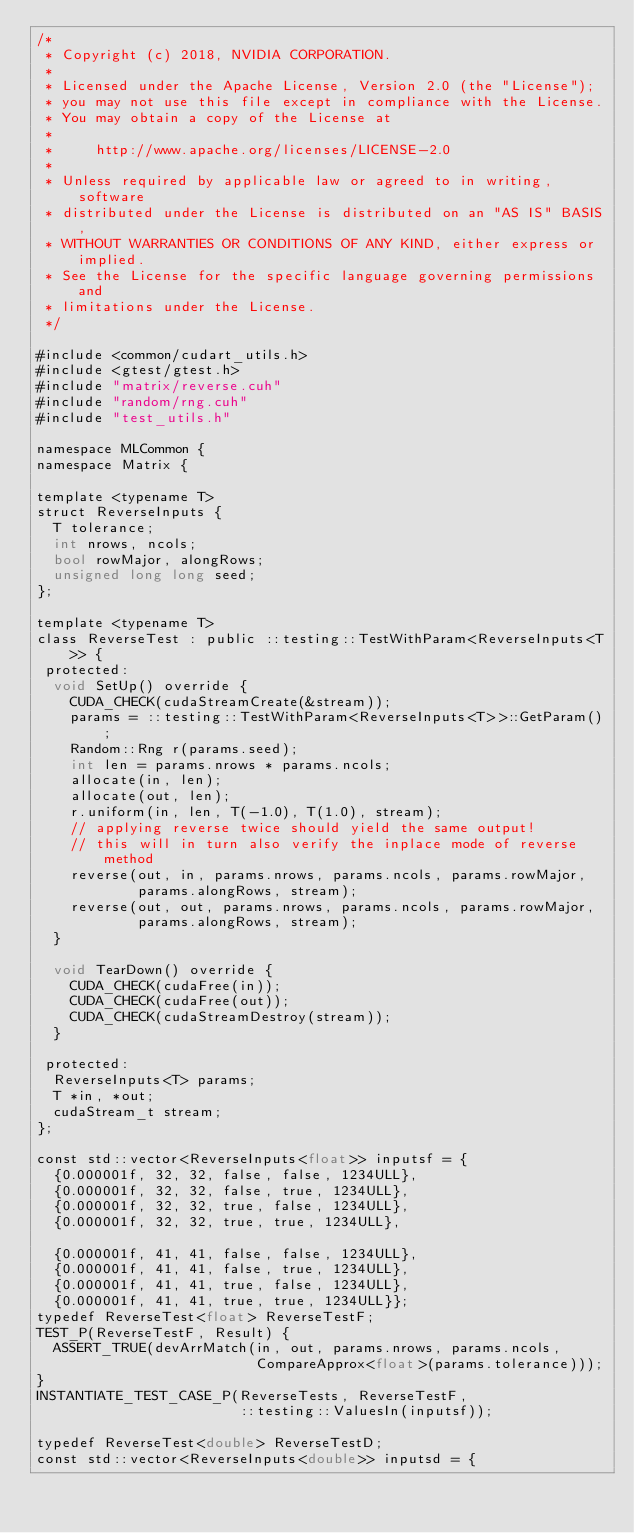<code> <loc_0><loc_0><loc_500><loc_500><_Cuda_>/*
 * Copyright (c) 2018, NVIDIA CORPORATION.
 *
 * Licensed under the Apache License, Version 2.0 (the "License");
 * you may not use this file except in compliance with the License.
 * You may obtain a copy of the License at
 *
 *     http://www.apache.org/licenses/LICENSE-2.0
 *
 * Unless required by applicable law or agreed to in writing, software
 * distributed under the License is distributed on an "AS IS" BASIS,
 * WITHOUT WARRANTIES OR CONDITIONS OF ANY KIND, either express or implied.
 * See the License for the specific language governing permissions and
 * limitations under the License.
 */

#include <common/cudart_utils.h>
#include <gtest/gtest.h>
#include "matrix/reverse.cuh"
#include "random/rng.cuh"
#include "test_utils.h"

namespace MLCommon {
namespace Matrix {

template <typename T>
struct ReverseInputs {
  T tolerance;
  int nrows, ncols;
  bool rowMajor, alongRows;
  unsigned long long seed;
};

template <typename T>
class ReverseTest : public ::testing::TestWithParam<ReverseInputs<T>> {
 protected:
  void SetUp() override {
    CUDA_CHECK(cudaStreamCreate(&stream));
    params = ::testing::TestWithParam<ReverseInputs<T>>::GetParam();
    Random::Rng r(params.seed);
    int len = params.nrows * params.ncols;
    allocate(in, len);
    allocate(out, len);
    r.uniform(in, len, T(-1.0), T(1.0), stream);
    // applying reverse twice should yield the same output!
    // this will in turn also verify the inplace mode of reverse method
    reverse(out, in, params.nrows, params.ncols, params.rowMajor,
            params.alongRows, stream);
    reverse(out, out, params.nrows, params.ncols, params.rowMajor,
            params.alongRows, stream);
  }

  void TearDown() override {
    CUDA_CHECK(cudaFree(in));
    CUDA_CHECK(cudaFree(out));
    CUDA_CHECK(cudaStreamDestroy(stream));
  }

 protected:
  ReverseInputs<T> params;
  T *in, *out;
  cudaStream_t stream;
};

const std::vector<ReverseInputs<float>> inputsf = {
  {0.000001f, 32, 32, false, false, 1234ULL},
  {0.000001f, 32, 32, false, true, 1234ULL},
  {0.000001f, 32, 32, true, false, 1234ULL},
  {0.000001f, 32, 32, true, true, 1234ULL},

  {0.000001f, 41, 41, false, false, 1234ULL},
  {0.000001f, 41, 41, false, true, 1234ULL},
  {0.000001f, 41, 41, true, false, 1234ULL},
  {0.000001f, 41, 41, true, true, 1234ULL}};
typedef ReverseTest<float> ReverseTestF;
TEST_P(ReverseTestF, Result) {
  ASSERT_TRUE(devArrMatch(in, out, params.nrows, params.ncols,
                          CompareApprox<float>(params.tolerance)));
}
INSTANTIATE_TEST_CASE_P(ReverseTests, ReverseTestF,
                        ::testing::ValuesIn(inputsf));

typedef ReverseTest<double> ReverseTestD;
const std::vector<ReverseInputs<double>> inputsd = {</code> 